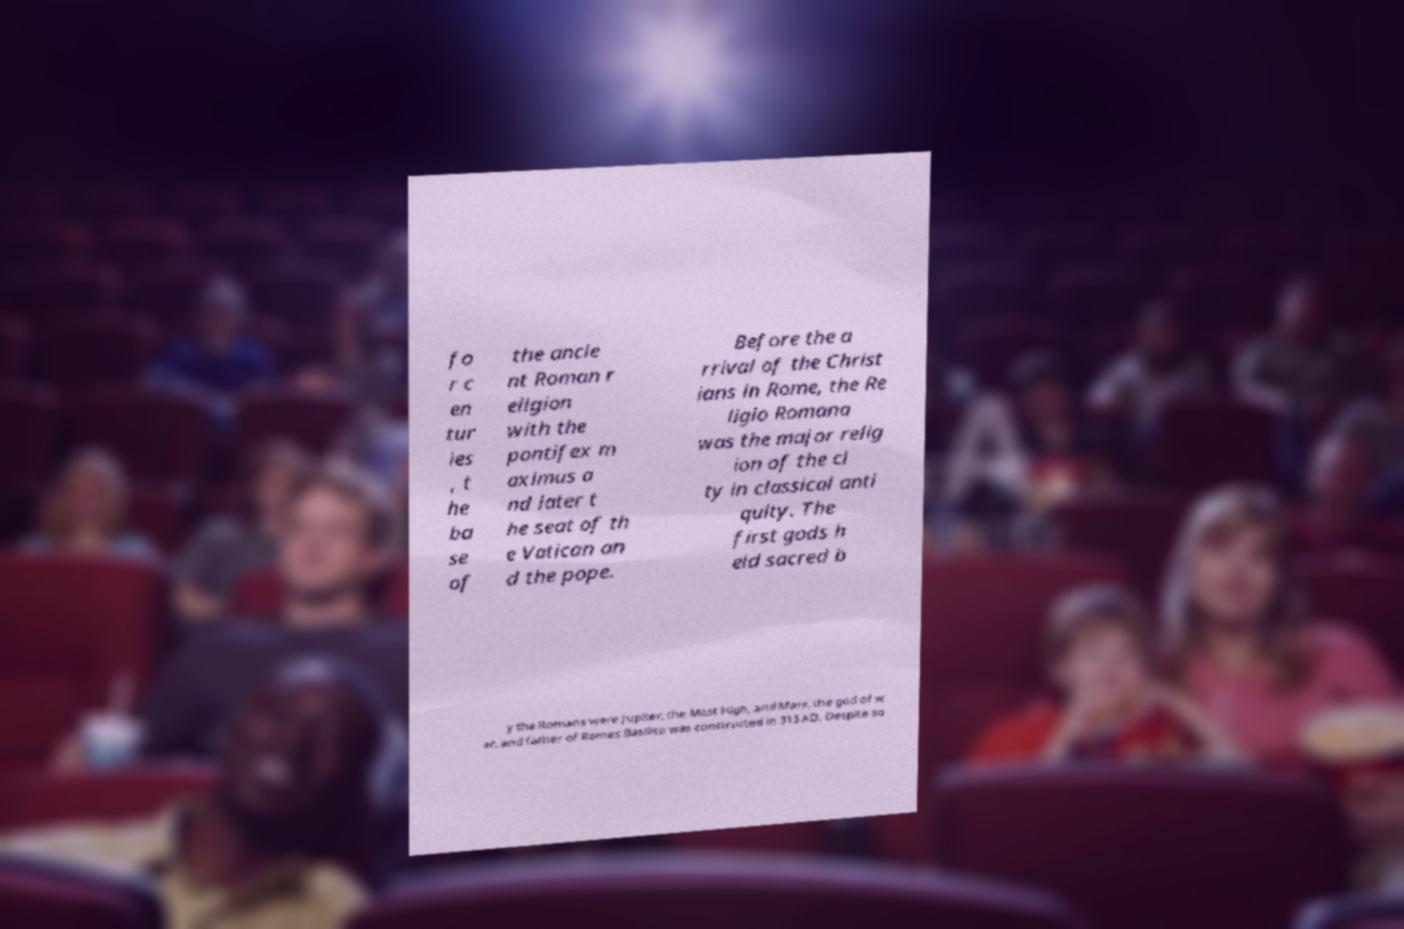What messages or text are displayed in this image? I need them in a readable, typed format. fo r c en tur ies , t he ba se of the ancie nt Roman r eligion with the pontifex m aximus a nd later t he seat of th e Vatican an d the pope. Before the a rrival of the Christ ians in Rome, the Re ligio Romana was the major relig ion of the ci ty in classical anti quity. The first gods h eld sacred b y the Romans were Jupiter, the Most High, and Mars, the god of w ar, and father of Romes Basilica was constructed in 313 AD. Despite so 